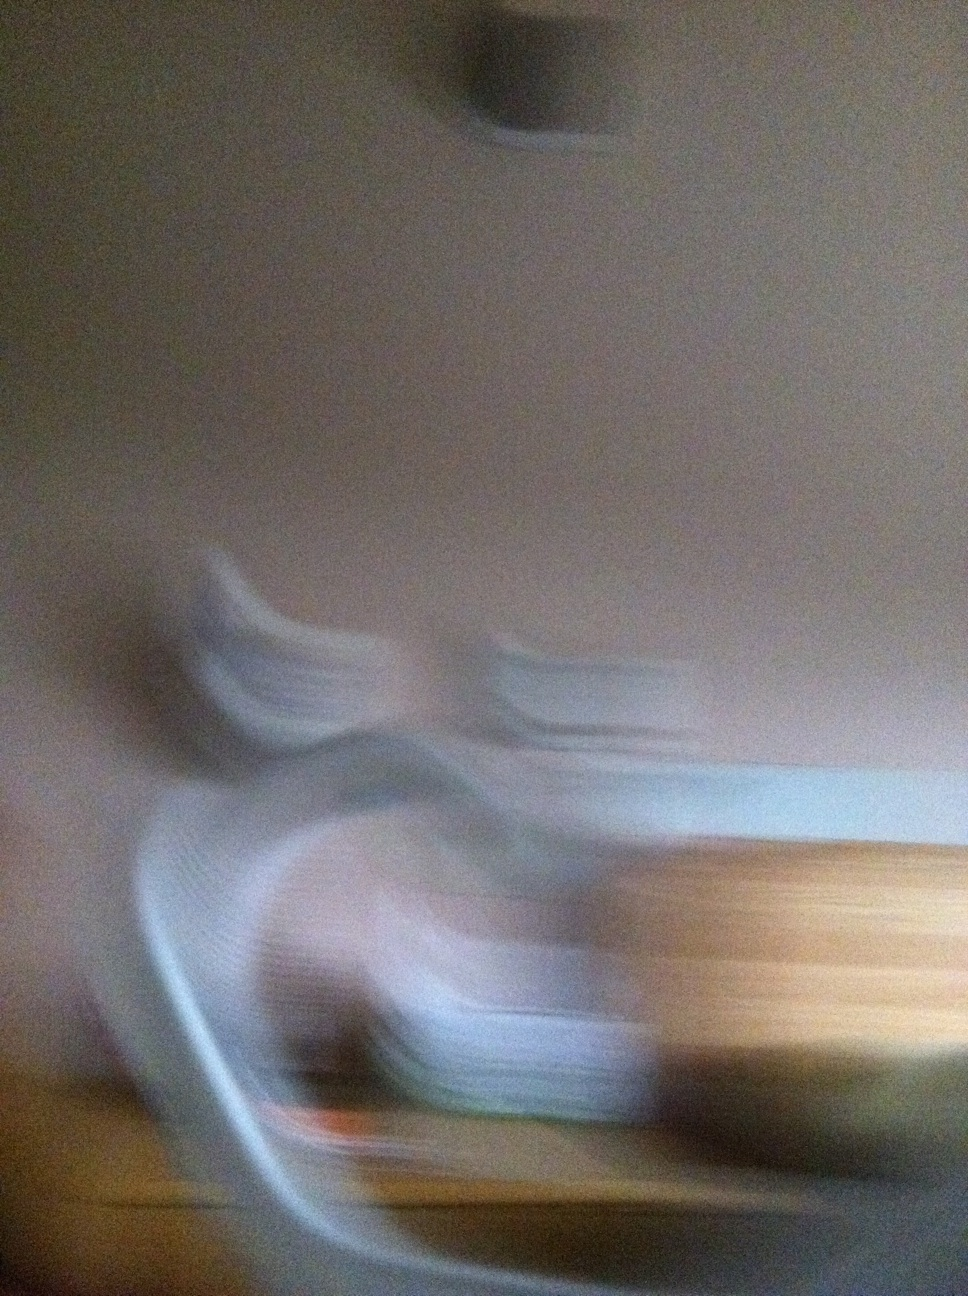What can you infer from this blurry image? The image appears to be heavily blurred, likely caused by a motion or a slow shutter speed. From the abstract shapes and colors, it is challenging to identify specific objects, but it seems to be an indoor setting with potential furniture items. The blur adds an artistic and intriguing element to the photo. Could this image reflect a certain mood or feeling? Yes, blurry images like this can evoke different feelings or moods. The abstract and unrefined nature of the blur can create a sense of mystery, motion, or confusion. It might make viewers feel unsettled, curious, or even introspective as they try to make sense of the ambiguous shapes. The colors and textures present can also contribute to the emotional impact. Imagine this blur is concealing an extraordinary world. What could be behind it? Imagine behind the blur lies a magnificent world where gravity works differently. The flowing shapes are actually floating islands, each a unique biome with vibrant ecosystems. Beneath, a vast sky with swirling colors like a perpetual sunset, teeming with flying creatures. Every blurred line represents an aurora of energy that sustains the islands, and hidden within are ancient relics of a civilization that once mastered the skies. The blend of motion and stillness creates a dreamlike atmosphere where one could discover endless wonders. 